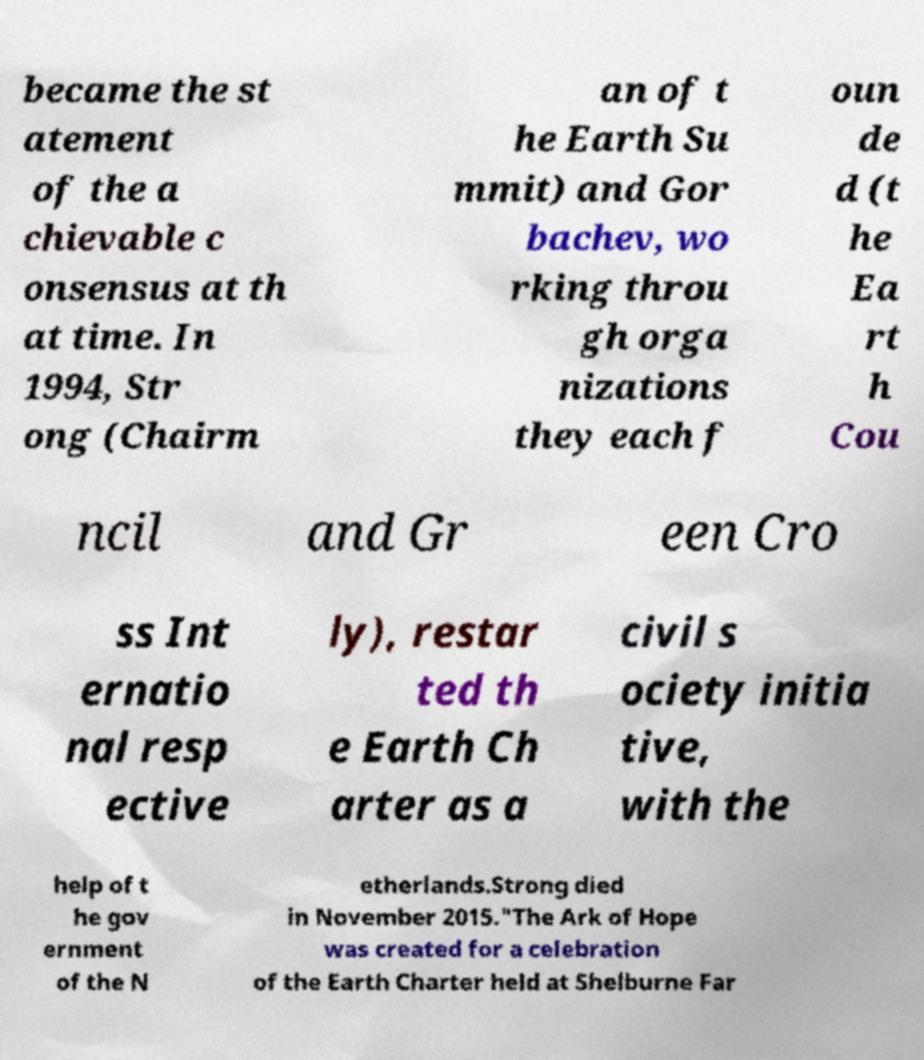There's text embedded in this image that I need extracted. Can you transcribe it verbatim? became the st atement of the a chievable c onsensus at th at time. In 1994, Str ong (Chairm an of t he Earth Su mmit) and Gor bachev, wo rking throu gh orga nizations they each f oun de d (t he Ea rt h Cou ncil and Gr een Cro ss Int ernatio nal resp ective ly), restar ted th e Earth Ch arter as a civil s ociety initia tive, with the help of t he gov ernment of the N etherlands.Strong died in November 2015."The Ark of Hope was created for a celebration of the Earth Charter held at Shelburne Far 